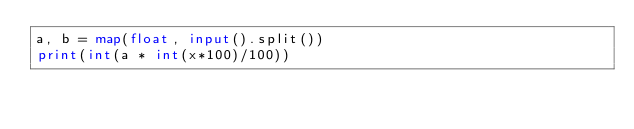<code> <loc_0><loc_0><loc_500><loc_500><_Python_>a, b = map(float, input().split())
print(int(a * int(x*100)/100))</code> 